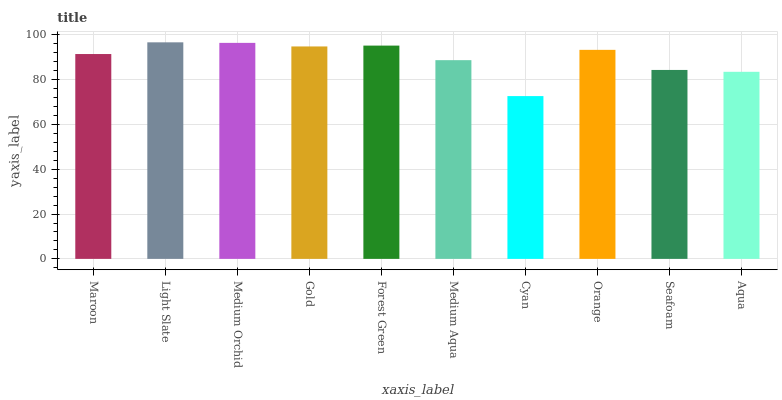Is Medium Orchid the minimum?
Answer yes or no. No. Is Medium Orchid the maximum?
Answer yes or no. No. Is Light Slate greater than Medium Orchid?
Answer yes or no. Yes. Is Medium Orchid less than Light Slate?
Answer yes or no. Yes. Is Medium Orchid greater than Light Slate?
Answer yes or no. No. Is Light Slate less than Medium Orchid?
Answer yes or no. No. Is Orange the high median?
Answer yes or no. Yes. Is Maroon the low median?
Answer yes or no. Yes. Is Seafoam the high median?
Answer yes or no. No. Is Gold the low median?
Answer yes or no. No. 